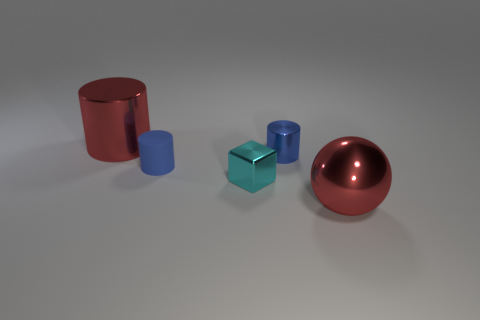What material is the big object that is the same color as the large metal sphere?
Your answer should be compact. Metal. Do the big shiny cylinder and the large metallic thing on the right side of the small blue matte cylinder have the same color?
Make the answer very short. Yes. What number of matte cylinders have the same color as the small shiny cylinder?
Keep it short and to the point. 1. Is the number of blue matte cylinders that are in front of the large red cylinder greater than the number of large metallic cylinders on the left side of the rubber cylinder?
Provide a succinct answer. No. What is the tiny blue object left of the small cyan thing made of?
Offer a terse response. Rubber. Is the blue metal object the same shape as the small cyan thing?
Offer a terse response. No. Is there any other thing of the same color as the metallic block?
Offer a very short reply. No. There is another shiny thing that is the same shape as the blue metallic thing; what is its color?
Give a very brief answer. Red. Are there more small cylinders in front of the small blue metallic object than small red metal cylinders?
Provide a short and direct response. Yes. What is the color of the big thing that is behind the tiny matte thing?
Ensure brevity in your answer.  Red. 